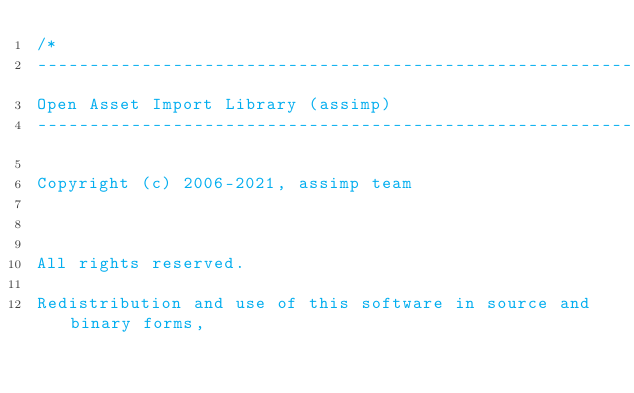Convert code to text. <code><loc_0><loc_0><loc_500><loc_500><_C++_>/*
---------------------------------------------------------------------------
Open Asset Import Library (assimp)
---------------------------------------------------------------------------

Copyright (c) 2006-2021, assimp team



All rights reserved.

Redistribution and use of this software in source and binary forms,</code> 